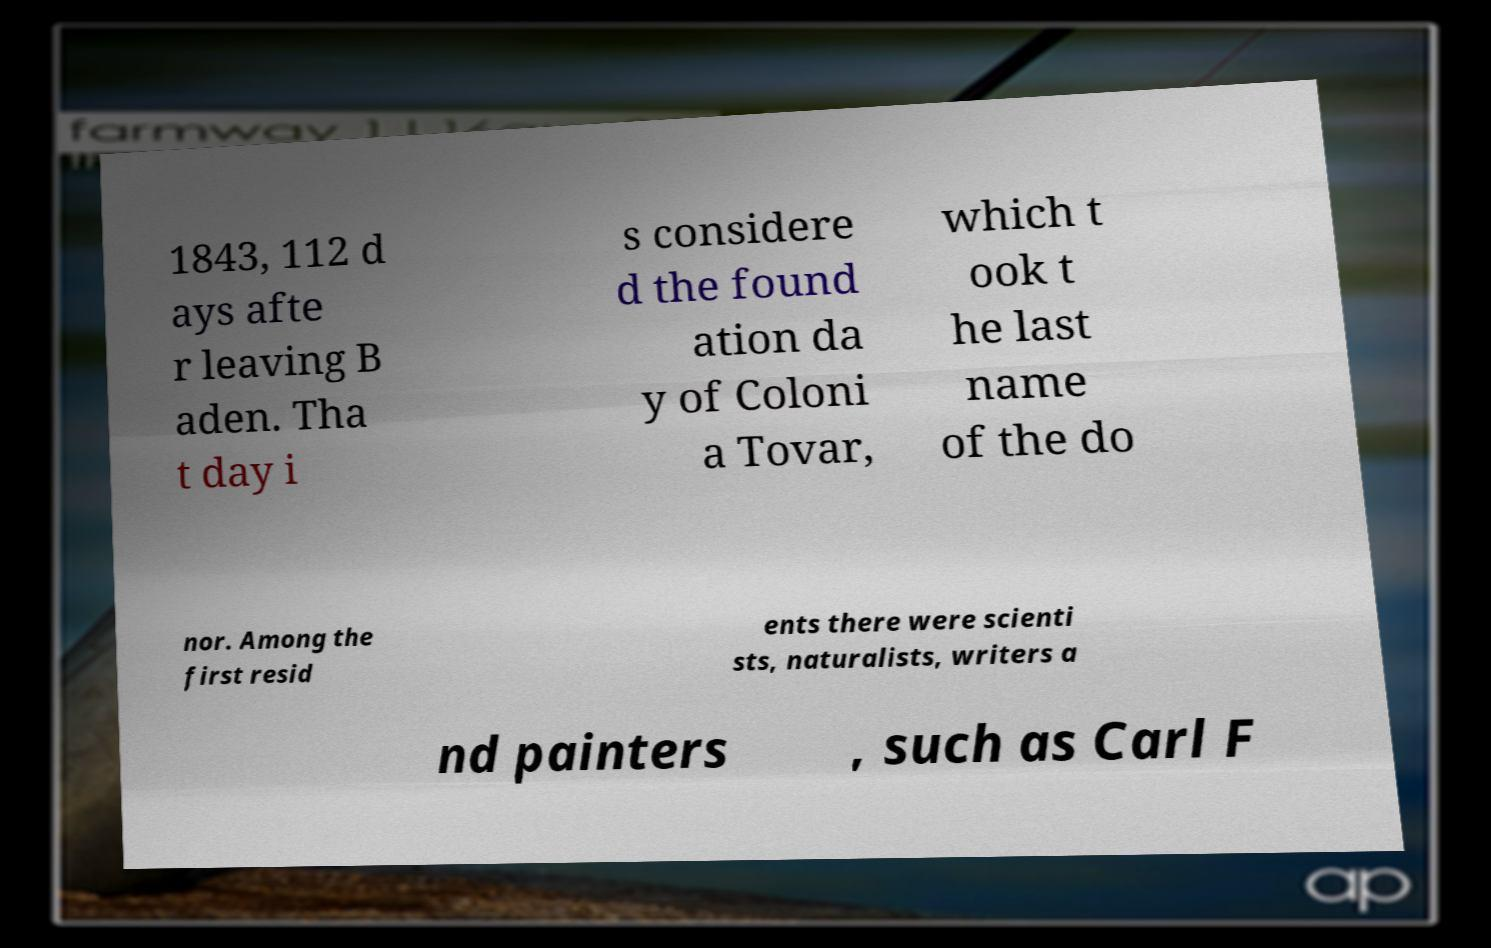For documentation purposes, I need the text within this image transcribed. Could you provide that? 1843, 112 d ays afte r leaving B aden. Tha t day i s considere d the found ation da y of Coloni a Tovar, which t ook t he last name of the do nor. Among the first resid ents there were scienti sts, naturalists, writers a nd painters , such as Carl F 